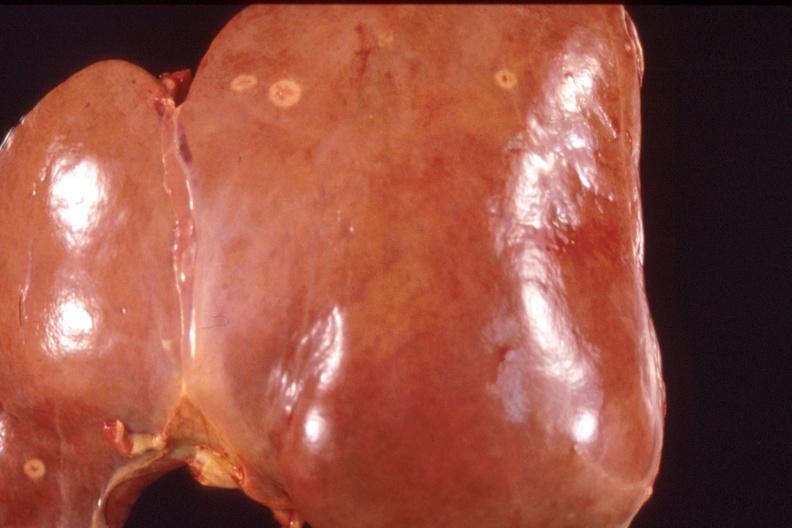what is present?
Answer the question using a single word or phrase. Hepatobiliary 